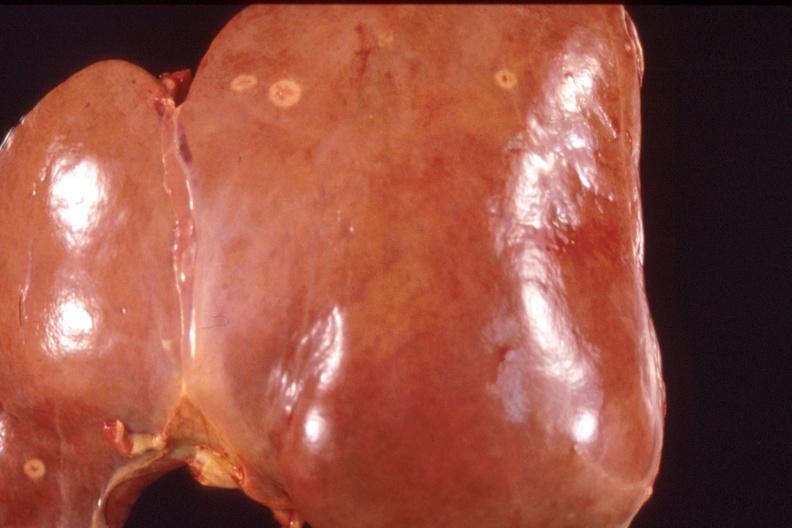what is present?
Answer the question using a single word or phrase. Hepatobiliary 